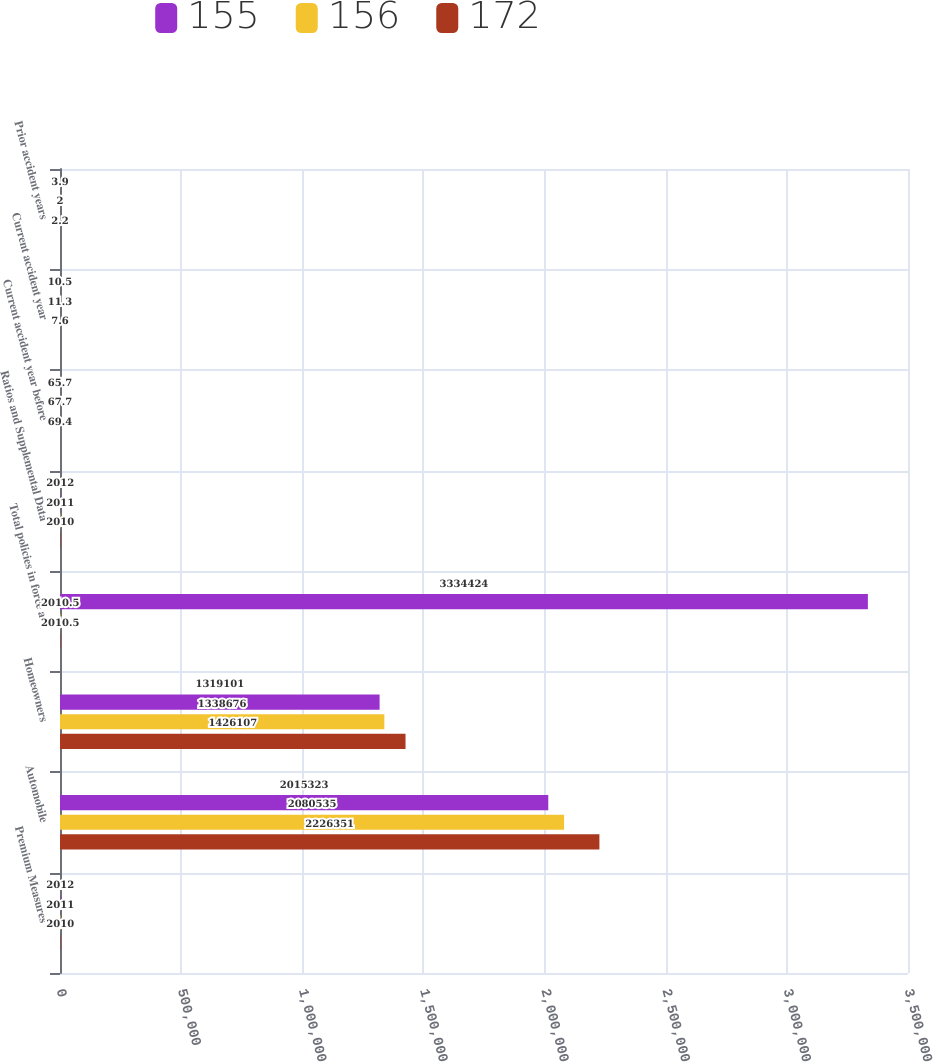Convert chart to OTSL. <chart><loc_0><loc_0><loc_500><loc_500><stacked_bar_chart><ecel><fcel>Premium Measures<fcel>Automobile<fcel>Homeowners<fcel>Total policies in force at<fcel>Ratios and Supplemental Data<fcel>Current accident year before<fcel>Current accident year<fcel>Prior accident years<nl><fcel>155<fcel>2012<fcel>2.01532e+06<fcel>1.3191e+06<fcel>3.33442e+06<fcel>2012<fcel>65.7<fcel>10.5<fcel>3.9<nl><fcel>156<fcel>2011<fcel>2.08054e+06<fcel>1.33868e+06<fcel>2010.5<fcel>2011<fcel>67.7<fcel>11.3<fcel>2<nl><fcel>172<fcel>2010<fcel>2.22635e+06<fcel>1.42611e+06<fcel>2010.5<fcel>2010<fcel>69.4<fcel>7.6<fcel>2.2<nl></chart> 